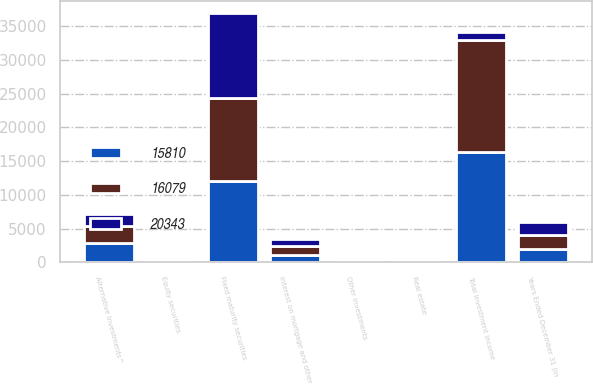<chart> <loc_0><loc_0><loc_500><loc_500><stacked_bar_chart><ecel><fcel>Years Ended December 31 (in<fcel>Fixed maturity securities<fcel>Equity securities<fcel>Interest on mortgage and other<fcel>Alternative investments^<fcel>Real estate<fcel>Other investments<fcel>Total investment income<nl><fcel>16079<fcel>2014<fcel>12322<fcel>221<fcel>1272<fcel>2624<fcel>110<fcel>47<fcel>16596<nl><fcel>15810<fcel>2013<fcel>12044<fcel>178<fcel>1144<fcel>2803<fcel>128<fcel>61<fcel>16358<nl><fcel>20343<fcel>2012<fcel>12592<fcel>162<fcel>1083<fcel>1769<fcel>127<fcel>11<fcel>1272<nl></chart> 